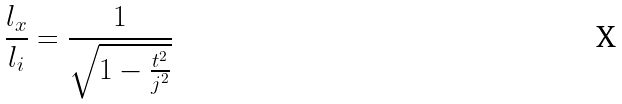<formula> <loc_0><loc_0><loc_500><loc_500>\frac { l _ { x } } { l _ { i } } = \frac { 1 } { \sqrt { 1 - \frac { t ^ { 2 } } { j ^ { 2 } } } }</formula> 